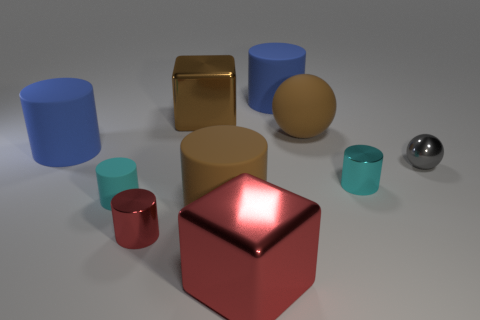Is there another small shiny sphere that has the same color as the tiny sphere?
Offer a very short reply. No. How many balls are either large brown matte things or red metallic objects?
Your response must be concise. 1. Are there any gray things of the same shape as the tiny red metal thing?
Your response must be concise. No. How many other objects are the same color as the small matte thing?
Keep it short and to the point. 1. Is the number of blue matte objects on the right side of the tiny gray thing less than the number of brown blocks?
Provide a succinct answer. Yes. What number of big green metal cylinders are there?
Keep it short and to the point. 0. How many small cylinders are the same material as the large red thing?
Your answer should be compact. 2. How many objects are large blue cylinders that are right of the red cylinder or cylinders?
Your answer should be very brief. 6. Is the number of objects behind the brown sphere less than the number of blue rubber cylinders that are left of the tiny red object?
Your answer should be compact. No. There is a cyan rubber cylinder; are there any big brown metal cubes in front of it?
Give a very brief answer. No. 